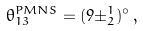<formula> <loc_0><loc_0><loc_500><loc_500>\theta _ { 1 3 } ^ { P M N S } = ( 9 \pm ^ { 1 } _ { 2 } ) ^ { \circ } \, ,</formula> 